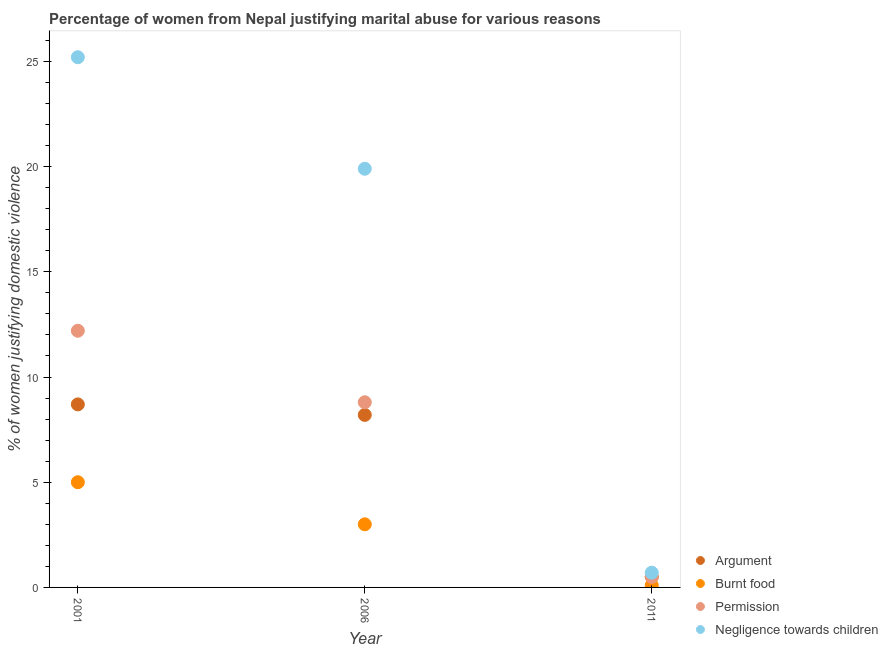How many different coloured dotlines are there?
Offer a terse response. 4. What is the percentage of women justifying abuse in the case of an argument in 2011?
Your answer should be very brief. 0.5. Across all years, what is the maximum percentage of women justifying abuse for going without permission?
Your answer should be very brief. 12.2. What is the total percentage of women justifying abuse for showing negligence towards children in the graph?
Your answer should be very brief. 45.8. What is the difference between the percentage of women justifying abuse in the case of an argument in 2006 and that in 2011?
Make the answer very short. 7.7. What is the difference between the percentage of women justifying abuse for burning food in 2001 and the percentage of women justifying abuse for showing negligence towards children in 2006?
Provide a short and direct response. -14.9. What is the average percentage of women justifying abuse in the case of an argument per year?
Ensure brevity in your answer.  5.8. In the year 2011, what is the difference between the percentage of women justifying abuse for showing negligence towards children and percentage of women justifying abuse for burning food?
Provide a succinct answer. 0.6. In how many years, is the percentage of women justifying abuse for burning food greater than 3 %?
Provide a short and direct response. 1. What is the ratio of the percentage of women justifying abuse for showing negligence towards children in 2006 to that in 2011?
Provide a succinct answer. 28.43. What is the difference between the highest and the second highest percentage of women justifying abuse for burning food?
Make the answer very short. 2. Is the sum of the percentage of women justifying abuse for burning food in 2001 and 2006 greater than the maximum percentage of women justifying abuse for going without permission across all years?
Give a very brief answer. No. Is it the case that in every year, the sum of the percentage of women justifying abuse for showing negligence towards children and percentage of women justifying abuse for burning food is greater than the sum of percentage of women justifying abuse in the case of an argument and percentage of women justifying abuse for going without permission?
Offer a terse response. No. Does the percentage of women justifying abuse for showing negligence towards children monotonically increase over the years?
Make the answer very short. No. How are the legend labels stacked?
Offer a terse response. Vertical. What is the title of the graph?
Provide a short and direct response. Percentage of women from Nepal justifying marital abuse for various reasons. Does "Structural Policies" appear as one of the legend labels in the graph?
Your answer should be compact. No. What is the label or title of the Y-axis?
Provide a succinct answer. % of women justifying domestic violence. What is the % of women justifying domestic violence in Argument in 2001?
Offer a very short reply. 8.7. What is the % of women justifying domestic violence in Negligence towards children in 2001?
Your answer should be very brief. 25.2. What is the % of women justifying domestic violence of Argument in 2006?
Keep it short and to the point. 8.2. What is the % of women justifying domestic violence in Burnt food in 2006?
Offer a very short reply. 3. What is the % of women justifying domestic violence of Permission in 2006?
Give a very brief answer. 8.8. What is the % of women justifying domestic violence of Burnt food in 2011?
Provide a short and direct response. 0.1. Across all years, what is the maximum % of women justifying domestic violence of Argument?
Provide a short and direct response. 8.7. Across all years, what is the maximum % of women justifying domestic violence in Permission?
Your answer should be compact. 12.2. Across all years, what is the maximum % of women justifying domestic violence in Negligence towards children?
Provide a short and direct response. 25.2. Across all years, what is the minimum % of women justifying domestic violence in Negligence towards children?
Your answer should be compact. 0.7. What is the total % of women justifying domestic violence of Argument in the graph?
Your response must be concise. 17.4. What is the total % of women justifying domestic violence of Negligence towards children in the graph?
Keep it short and to the point. 45.8. What is the difference between the % of women justifying domestic violence of Burnt food in 2001 and that in 2006?
Your answer should be compact. 2. What is the difference between the % of women justifying domestic violence in Negligence towards children in 2001 and that in 2006?
Offer a very short reply. 5.3. What is the difference between the % of women justifying domestic violence in Burnt food in 2001 and that in 2011?
Provide a succinct answer. 4.9. What is the difference between the % of women justifying domestic violence of Permission in 2001 and that in 2011?
Provide a short and direct response. 11.7. What is the difference between the % of women justifying domestic violence in Negligence towards children in 2001 and that in 2011?
Your answer should be compact. 24.5. What is the difference between the % of women justifying domestic violence in Argument in 2006 and that in 2011?
Ensure brevity in your answer.  7.7. What is the difference between the % of women justifying domestic violence in Burnt food in 2006 and that in 2011?
Offer a terse response. 2.9. What is the difference between the % of women justifying domestic violence in Permission in 2006 and that in 2011?
Offer a terse response. 8.3. What is the difference between the % of women justifying domestic violence of Negligence towards children in 2006 and that in 2011?
Provide a short and direct response. 19.2. What is the difference between the % of women justifying domestic violence of Argument in 2001 and the % of women justifying domestic violence of Negligence towards children in 2006?
Offer a very short reply. -11.2. What is the difference between the % of women justifying domestic violence in Burnt food in 2001 and the % of women justifying domestic violence in Permission in 2006?
Your response must be concise. -3.8. What is the difference between the % of women justifying domestic violence in Burnt food in 2001 and the % of women justifying domestic violence in Negligence towards children in 2006?
Your answer should be very brief. -14.9. What is the difference between the % of women justifying domestic violence in Permission in 2001 and the % of women justifying domestic violence in Negligence towards children in 2006?
Offer a terse response. -7.7. What is the difference between the % of women justifying domestic violence in Argument in 2001 and the % of women justifying domestic violence in Permission in 2011?
Provide a short and direct response. 8.2. What is the difference between the % of women justifying domestic violence in Argument in 2001 and the % of women justifying domestic violence in Negligence towards children in 2011?
Make the answer very short. 8. What is the difference between the % of women justifying domestic violence in Burnt food in 2001 and the % of women justifying domestic violence in Permission in 2011?
Your answer should be compact. 4.5. What is the difference between the % of women justifying domestic violence of Burnt food in 2001 and the % of women justifying domestic violence of Negligence towards children in 2011?
Your answer should be compact. 4.3. What is the difference between the % of women justifying domestic violence in Permission in 2001 and the % of women justifying domestic violence in Negligence towards children in 2011?
Your answer should be compact. 11.5. What is the average % of women justifying domestic violence of Argument per year?
Your answer should be compact. 5.8. What is the average % of women justifying domestic violence in Burnt food per year?
Your answer should be very brief. 2.7. What is the average % of women justifying domestic violence of Permission per year?
Give a very brief answer. 7.17. What is the average % of women justifying domestic violence of Negligence towards children per year?
Give a very brief answer. 15.27. In the year 2001, what is the difference between the % of women justifying domestic violence in Argument and % of women justifying domestic violence in Burnt food?
Keep it short and to the point. 3.7. In the year 2001, what is the difference between the % of women justifying domestic violence in Argument and % of women justifying domestic violence in Permission?
Your answer should be very brief. -3.5. In the year 2001, what is the difference between the % of women justifying domestic violence in Argument and % of women justifying domestic violence in Negligence towards children?
Your answer should be very brief. -16.5. In the year 2001, what is the difference between the % of women justifying domestic violence of Burnt food and % of women justifying domestic violence of Permission?
Offer a very short reply. -7.2. In the year 2001, what is the difference between the % of women justifying domestic violence of Burnt food and % of women justifying domestic violence of Negligence towards children?
Give a very brief answer. -20.2. In the year 2001, what is the difference between the % of women justifying domestic violence of Permission and % of women justifying domestic violence of Negligence towards children?
Make the answer very short. -13. In the year 2006, what is the difference between the % of women justifying domestic violence of Argument and % of women justifying domestic violence of Burnt food?
Make the answer very short. 5.2. In the year 2006, what is the difference between the % of women justifying domestic violence of Burnt food and % of women justifying domestic violence of Permission?
Your answer should be compact. -5.8. In the year 2006, what is the difference between the % of women justifying domestic violence in Burnt food and % of women justifying domestic violence in Negligence towards children?
Provide a short and direct response. -16.9. In the year 2006, what is the difference between the % of women justifying domestic violence in Permission and % of women justifying domestic violence in Negligence towards children?
Keep it short and to the point. -11.1. In the year 2011, what is the difference between the % of women justifying domestic violence in Argument and % of women justifying domestic violence in Negligence towards children?
Provide a short and direct response. -0.2. In the year 2011, what is the difference between the % of women justifying domestic violence of Burnt food and % of women justifying domestic violence of Negligence towards children?
Ensure brevity in your answer.  -0.6. What is the ratio of the % of women justifying domestic violence of Argument in 2001 to that in 2006?
Give a very brief answer. 1.06. What is the ratio of the % of women justifying domestic violence in Permission in 2001 to that in 2006?
Your answer should be very brief. 1.39. What is the ratio of the % of women justifying domestic violence of Negligence towards children in 2001 to that in 2006?
Offer a terse response. 1.27. What is the ratio of the % of women justifying domestic violence of Burnt food in 2001 to that in 2011?
Ensure brevity in your answer.  50. What is the ratio of the % of women justifying domestic violence in Permission in 2001 to that in 2011?
Your answer should be compact. 24.4. What is the ratio of the % of women justifying domestic violence in Negligence towards children in 2001 to that in 2011?
Ensure brevity in your answer.  36. What is the ratio of the % of women justifying domestic violence in Burnt food in 2006 to that in 2011?
Ensure brevity in your answer.  30. What is the ratio of the % of women justifying domestic violence of Permission in 2006 to that in 2011?
Your answer should be very brief. 17.6. What is the ratio of the % of women justifying domestic violence in Negligence towards children in 2006 to that in 2011?
Provide a short and direct response. 28.43. What is the difference between the highest and the second highest % of women justifying domestic violence in Permission?
Give a very brief answer. 3.4. What is the difference between the highest and the second highest % of women justifying domestic violence in Negligence towards children?
Make the answer very short. 5.3. What is the difference between the highest and the lowest % of women justifying domestic violence of Argument?
Make the answer very short. 8.2. What is the difference between the highest and the lowest % of women justifying domestic violence of Burnt food?
Make the answer very short. 4.9. What is the difference between the highest and the lowest % of women justifying domestic violence of Permission?
Offer a very short reply. 11.7. What is the difference between the highest and the lowest % of women justifying domestic violence of Negligence towards children?
Your response must be concise. 24.5. 